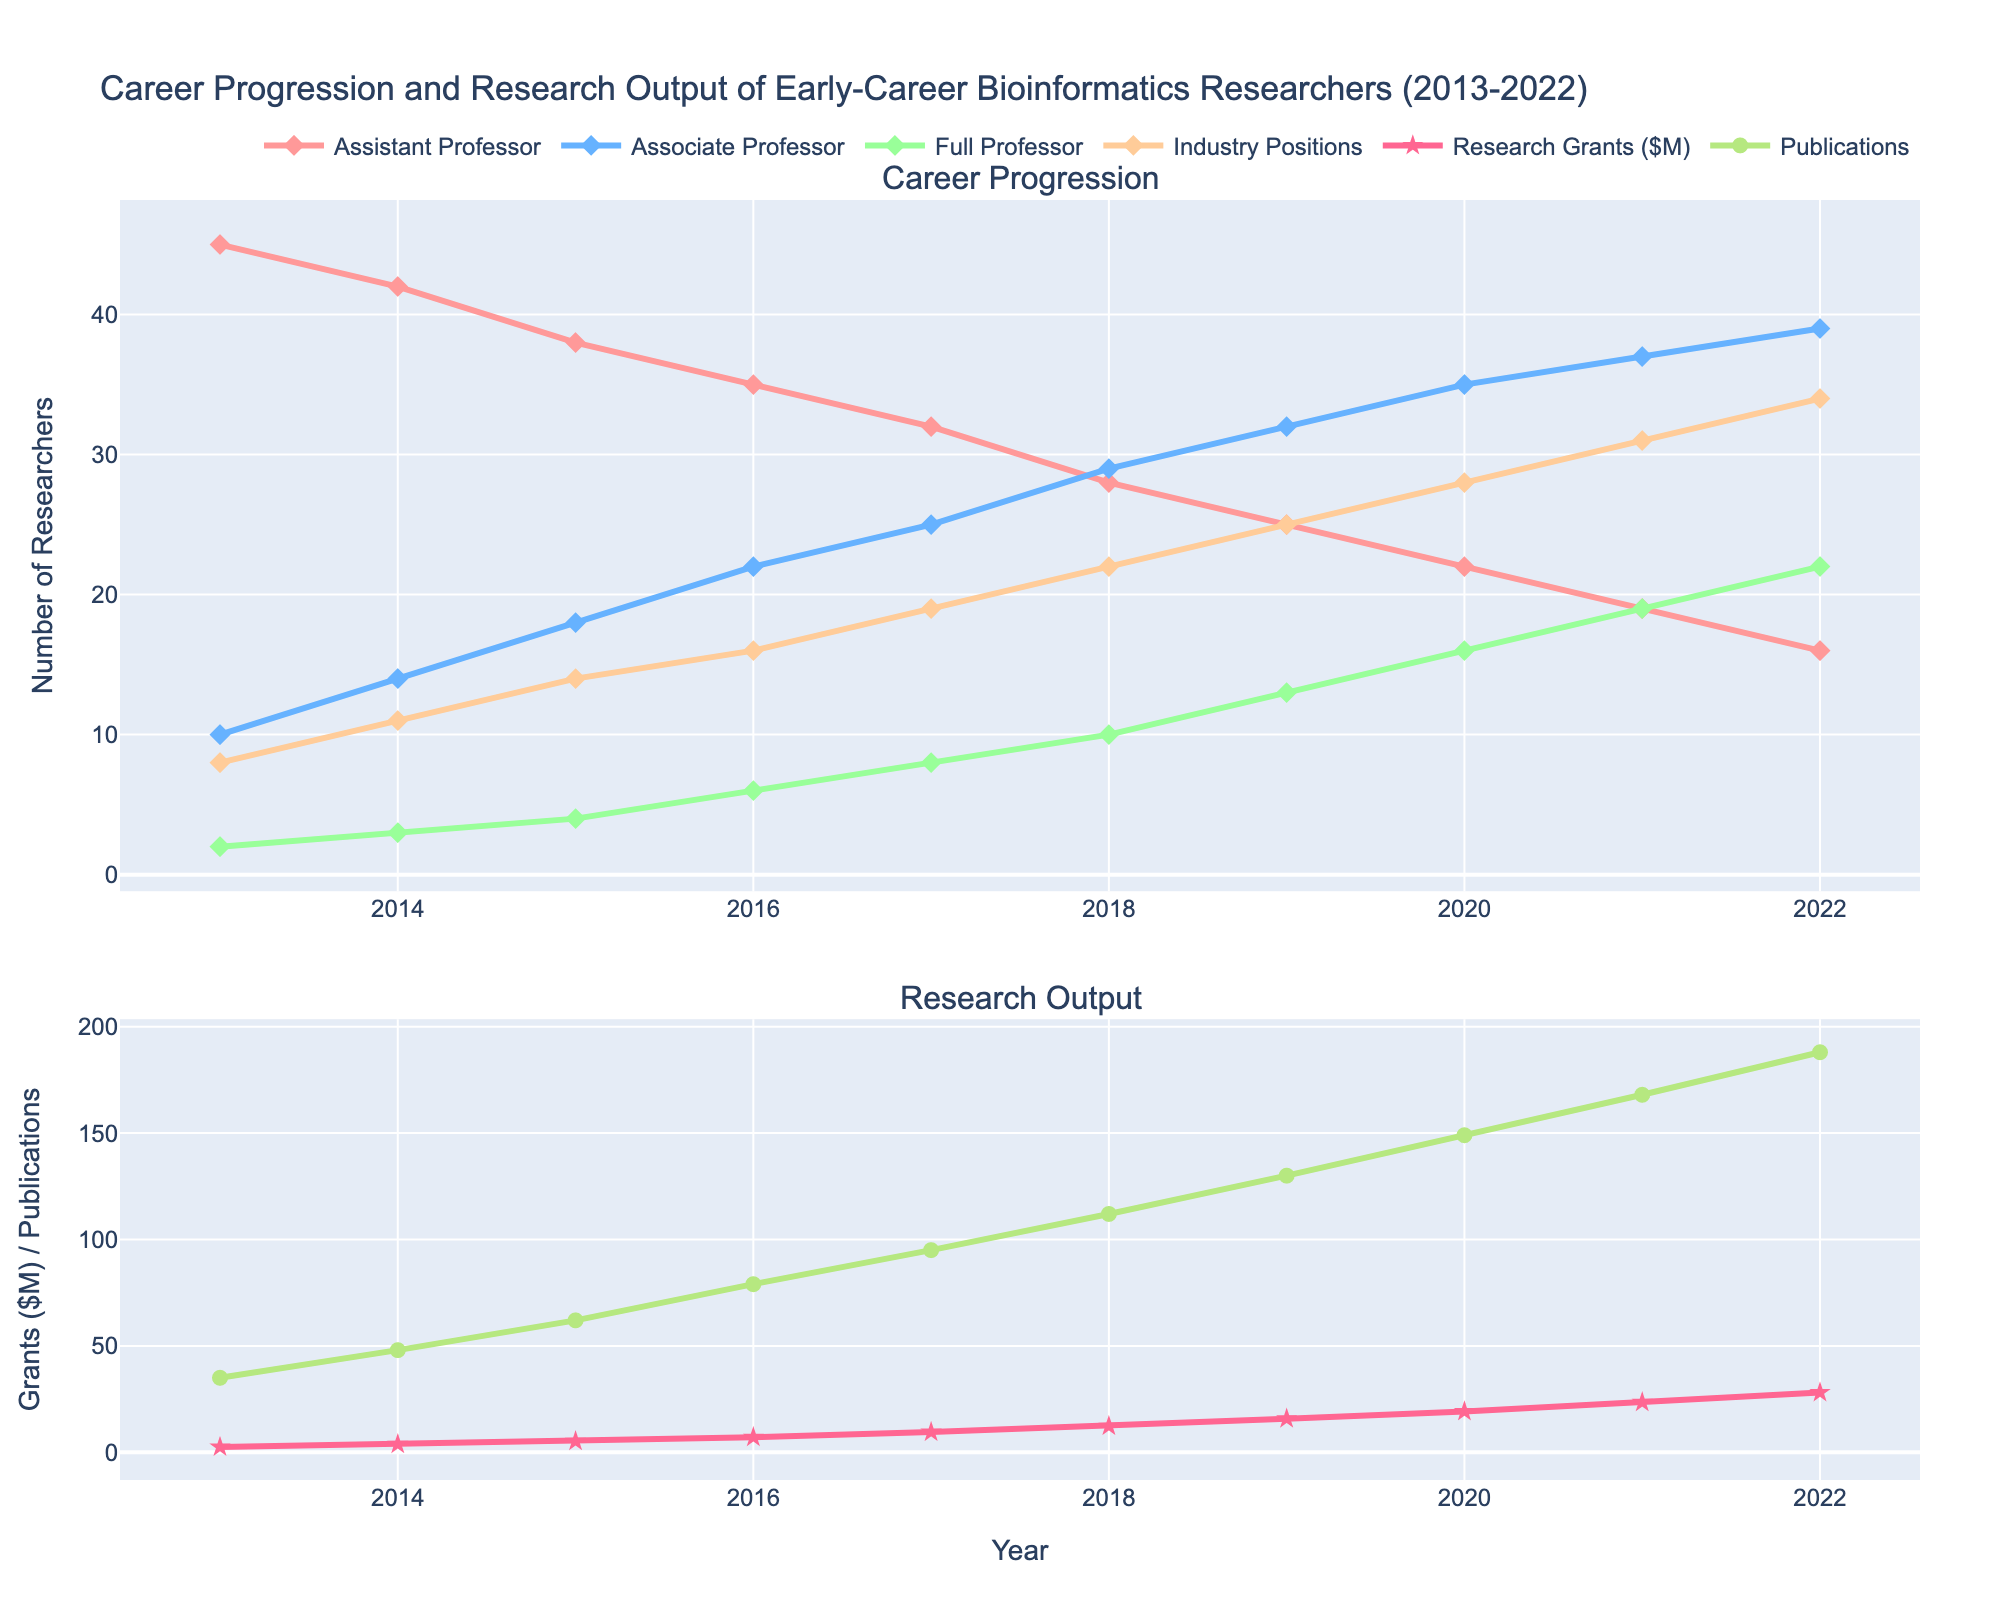What's the overall trend for the number of Assistant Professors from 2013 to 2022? The line representing Assistant Professors consistently decreases from 45 in 2013 to 16 in 2022, indicating a downward trend.
Answer: Downward Which year saw the highest number of researchers in Industry Positions? Referring to the line for Industry Positions, it peaks in 2022 with 34 researchers.
Answer: 2022 How did the total number of Full Professors change between 2015 and 2020? In 2015, the number was 4. In 2020, it increased to 16. Therefore, the change is 16 - 4 = 12.
Answer: Increased by 12 What is the difference in research grants secured between 2014 and 2019? Research grants secured in 2014 were $3.8M, and in 2019, they were $15.8M. The difference is $15.8M - $3.8M = $12M.
Answer: $12M Compare the number of Publications in High-Impact Journals in 2016 and 2022. Which year had more? In 2016, there were 79 publications. In 2022, there were 188. Thus, 2022 had more publications.
Answer: 2022 What are the colors used to represent Associate Professors and Industry Positions? Associate Professors are represented in blue, and Industry Positions are in orange.
Answer: Blue and orange Calculate the average number of Associate Professors from 2013 to 2017. The numbers are 10, 14, 18, 22, and 25. The sum is 89 and there are 5 years, so the average is 89 / 5 = 17.8.
Answer: 17.8 Which group had the slowest growth in numbers over the 10-year period? Full Professors increased from 2 to 22, a growth of 20. Associate Professors increased from 10 to 39, a growth of 29. Industry Positions increased from 8 to 34, a growth of 26. Assistant Professors decreased. Hence, Full Professors had the slowest growth.
Answer: Full Professors In which year did the number of Assistant Professors drop below 30? Referring to the chart, the number dropped below 30 in the year 2018 when it was 28.
Answer: 2018 